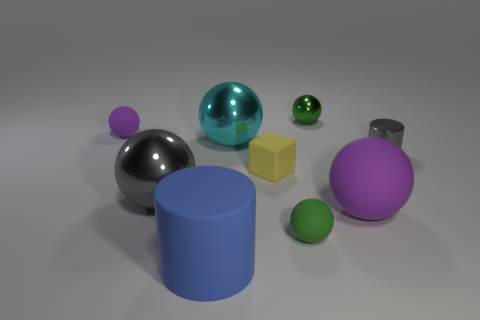Subtract 2 spheres. How many spheres are left? 4 Subtract all cyan spheres. How many spheres are left? 5 Subtract all large cyan spheres. How many spheres are left? 5 Subtract all brown balls. Subtract all cyan blocks. How many balls are left? 6 Add 1 big purple matte objects. How many objects exist? 10 Subtract all cylinders. How many objects are left? 7 Add 7 metallic cylinders. How many metallic cylinders are left? 8 Add 3 large purple spheres. How many large purple spheres exist? 4 Subtract 0 blue spheres. How many objects are left? 9 Subtract all blue matte objects. Subtract all large blue matte cylinders. How many objects are left? 7 